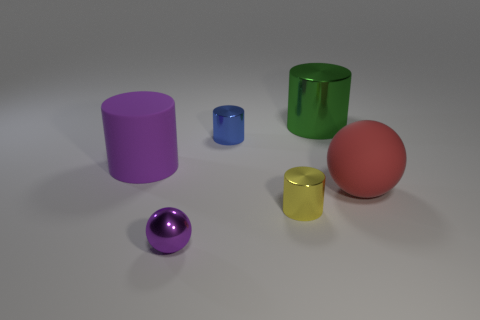Subtract all small yellow shiny cylinders. How many cylinders are left? 3 Subtract all red balls. How many balls are left? 1 Subtract all balls. How many objects are left? 4 Add 3 large cylinders. How many objects exist? 9 Subtract 1 spheres. How many spheres are left? 1 Subtract all large rubber cylinders. Subtract all large rubber objects. How many objects are left? 3 Add 6 green metallic objects. How many green metallic objects are left? 7 Add 1 tiny purple metallic spheres. How many tiny purple metallic spheres exist? 2 Subtract 1 green cylinders. How many objects are left? 5 Subtract all gray spheres. Subtract all purple blocks. How many spheres are left? 2 